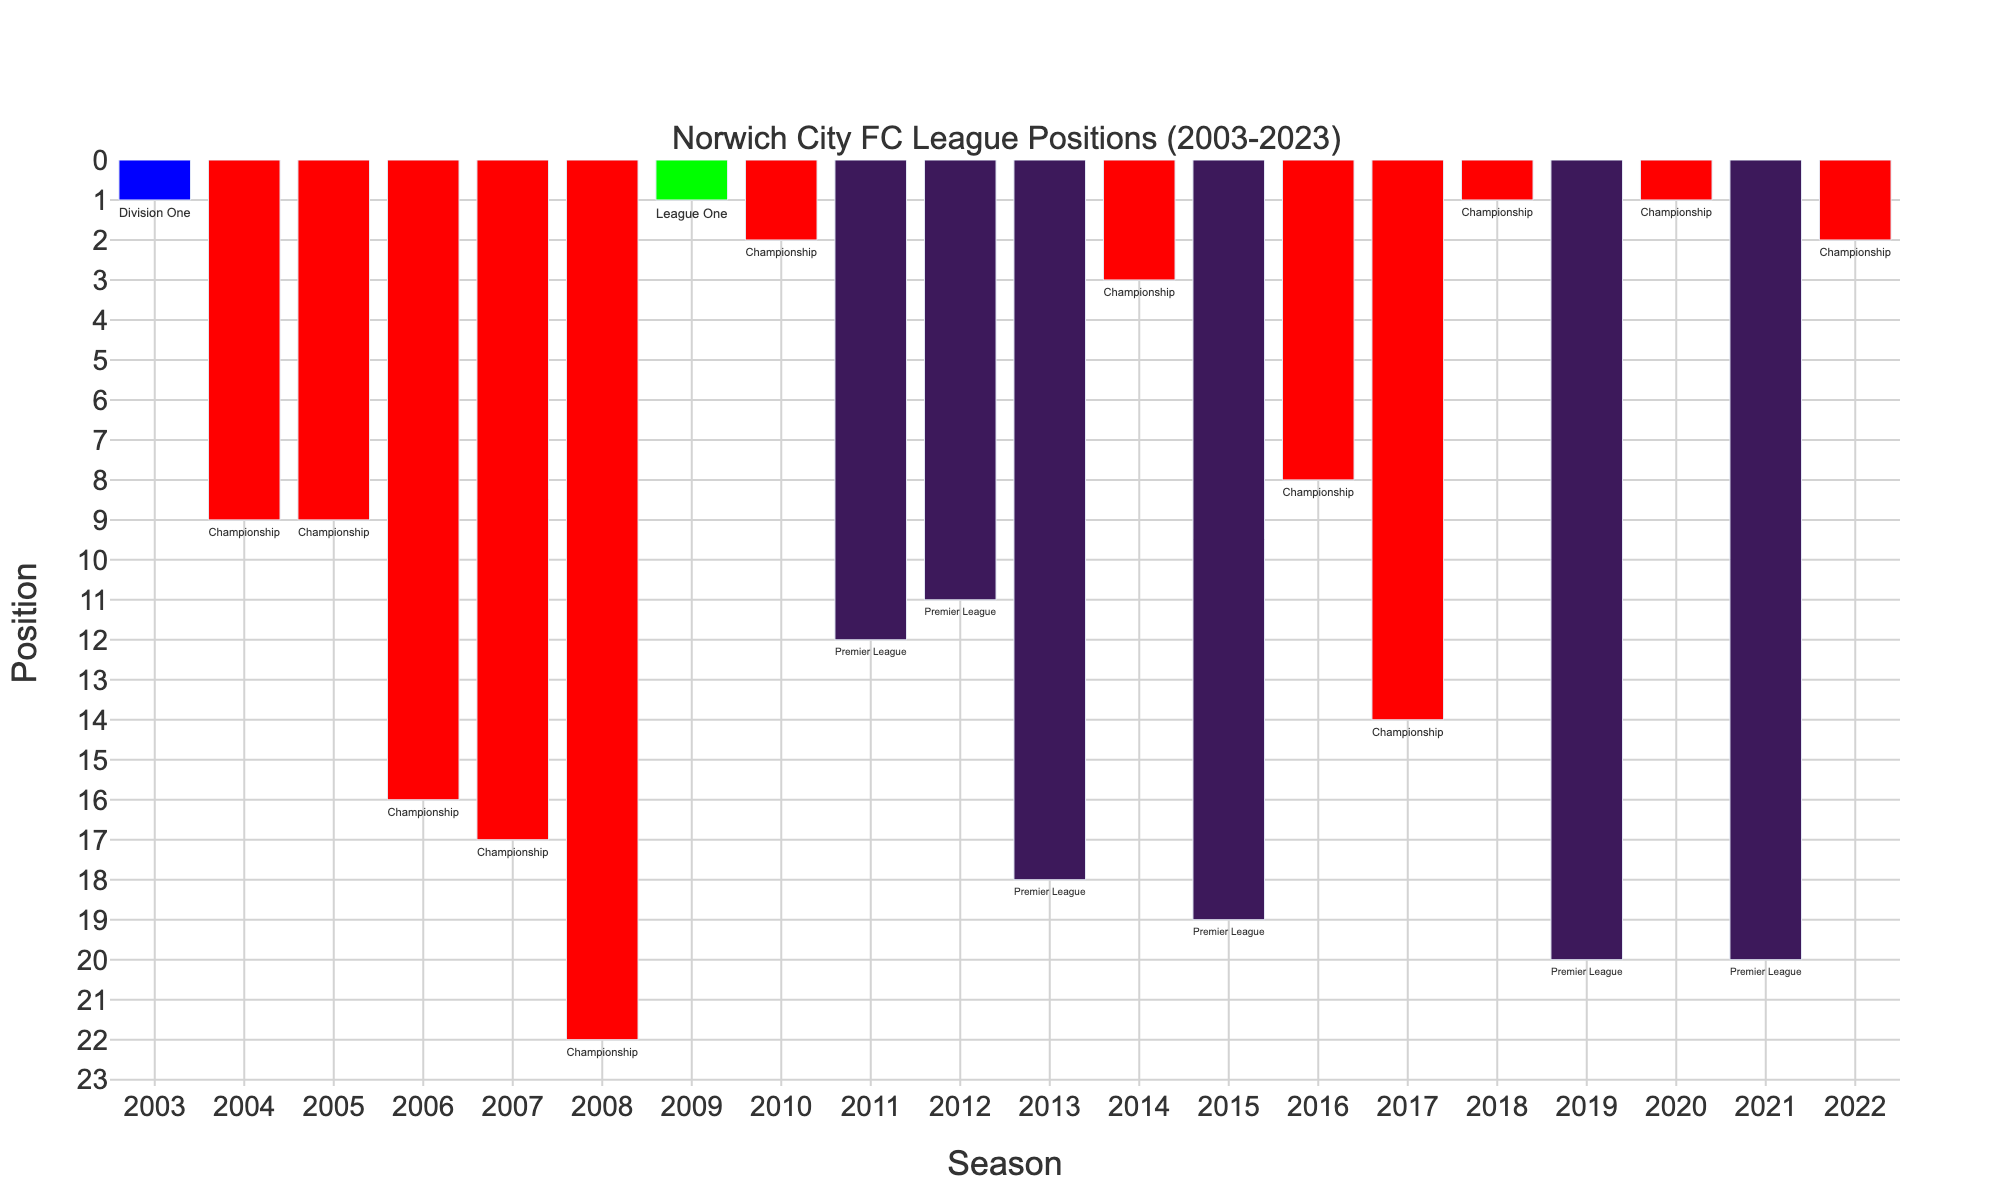Which season did Norwich City finish 1st in the Championship twice? By looking at the bars colored in red (Championship) and identifying those with a height of 1, we see that Norwich City finished 1st in the Championship in 2018-2019 and 2020-2021 seasons.
Answer: 2018-2019, 2020-2021 What was the highest position Norwich City achieved in the Premier League? The bars colored in dark blue represent the Premier League. The highest bar among them has a value of 11, achieved in the 2012-2013 season.
Answer: 11 In how many seasons did Norwich City finish in the bottom five positions across all leagues? Identify bars with a height greater than or equal to 18 (since we're using reversed order). These are found in the 2021-2022, 2019-2020, 2015-2016, 2013-2014, and 2008-2009 seasons, totaling 5 seasons.
Answer: 5 Which season had Norwich City at the lowest position in the Championship? Count bars in red (Championship). The lowest position in this league is 22, which corresponds to the 2008-2009 season.
Answer: 2008-2009 Compare the number of seasons Norwich City played in the Premier League versus the Championship. Count the number of bars colored in dark blue (Premier League) and in red (Championship). There are 7 seasons in the Premier League and 11 seasons in the Championship.
Answer: 7 Premier League, 11 Championship In which different leagues has Norwich City finished in 1st place over the last 20 years? Look for bars with a height of 1 and check the annotations (league names) next to them. Norwich City finished 1st in the Championship (2018-2019, 2020-2021), League One (2009-2010), and Division One (2003-2004).
Answer: Championship, League One, Division One Calculate the average finish position in the Championship over the last 20 years. List Championship positions: 2, 1, 1, 14, 8, 3, 2, 22, 17, 16, 9, 9, and find their average: (2 + 1 + 1 + 14 + 8 + 3 + 2 + 22 + 17 + 16 + 9 + 9) / 12 = 8.5.
Answer: 8.5 Which season did Norwich City achieve its best position in Division One? Identify the bar color-coded for Division One (blue) and find the highest bar. Norwich finished 1st in the 2003-2004 season.
Answer: 2003-2004 How many times did Norwich City achieve promotion by finishing in a top 3 spot in the Championship? Championship top positions: 2, 1, 1, 3, 2 results in 5 promotions.
Answer: 5 